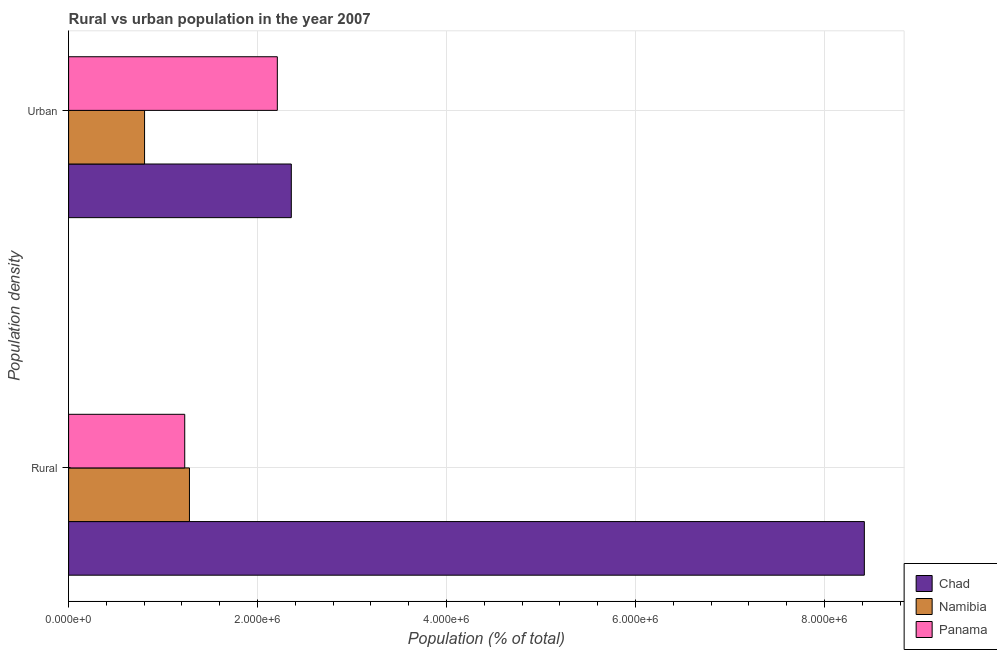Are the number of bars per tick equal to the number of legend labels?
Your answer should be compact. Yes. How many bars are there on the 2nd tick from the top?
Your response must be concise. 3. What is the label of the 2nd group of bars from the top?
Provide a short and direct response. Rural. What is the urban population density in Panama?
Keep it short and to the point. 2.21e+06. Across all countries, what is the maximum urban population density?
Offer a terse response. 2.36e+06. Across all countries, what is the minimum urban population density?
Keep it short and to the point. 8.04e+05. In which country was the rural population density maximum?
Offer a very short reply. Chad. In which country was the urban population density minimum?
Provide a short and direct response. Namibia. What is the total rural population density in the graph?
Provide a succinct answer. 1.09e+07. What is the difference between the urban population density in Chad and that in Panama?
Ensure brevity in your answer.  1.48e+05. What is the difference between the rural population density in Panama and the urban population density in Chad?
Your answer should be compact. -1.13e+06. What is the average rural population density per country?
Give a very brief answer. 3.64e+06. What is the difference between the urban population density and rural population density in Namibia?
Give a very brief answer. -4.75e+05. What is the ratio of the urban population density in Panama to that in Namibia?
Give a very brief answer. 2.75. What does the 1st bar from the top in Rural represents?
Your answer should be compact. Panama. What does the 3rd bar from the bottom in Rural represents?
Ensure brevity in your answer.  Panama. How many bars are there?
Offer a very short reply. 6. What is the difference between two consecutive major ticks on the X-axis?
Your answer should be very brief. 2.00e+06. Are the values on the major ticks of X-axis written in scientific E-notation?
Offer a very short reply. Yes. Where does the legend appear in the graph?
Provide a succinct answer. Bottom right. How many legend labels are there?
Ensure brevity in your answer.  3. What is the title of the graph?
Give a very brief answer. Rural vs urban population in the year 2007. Does "Armenia" appear as one of the legend labels in the graph?
Make the answer very short. No. What is the label or title of the X-axis?
Offer a very short reply. Population (% of total). What is the label or title of the Y-axis?
Ensure brevity in your answer.  Population density. What is the Population (% of total) in Chad in Rural?
Offer a very short reply. 8.42e+06. What is the Population (% of total) in Namibia in Rural?
Ensure brevity in your answer.  1.28e+06. What is the Population (% of total) of Panama in Rural?
Provide a short and direct response. 1.23e+06. What is the Population (% of total) in Chad in Urban?
Keep it short and to the point. 2.36e+06. What is the Population (% of total) of Namibia in Urban?
Make the answer very short. 8.04e+05. What is the Population (% of total) in Panama in Urban?
Ensure brevity in your answer.  2.21e+06. Across all Population density, what is the maximum Population (% of total) in Chad?
Give a very brief answer. 8.42e+06. Across all Population density, what is the maximum Population (% of total) of Namibia?
Make the answer very short. 1.28e+06. Across all Population density, what is the maximum Population (% of total) of Panama?
Provide a succinct answer. 2.21e+06. Across all Population density, what is the minimum Population (% of total) of Chad?
Offer a terse response. 2.36e+06. Across all Population density, what is the minimum Population (% of total) in Namibia?
Offer a very short reply. 8.04e+05. Across all Population density, what is the minimum Population (% of total) of Panama?
Make the answer very short. 1.23e+06. What is the total Population (% of total) in Chad in the graph?
Offer a very short reply. 1.08e+07. What is the total Population (% of total) of Namibia in the graph?
Keep it short and to the point. 2.08e+06. What is the total Population (% of total) in Panama in the graph?
Your answer should be compact. 3.44e+06. What is the difference between the Population (% of total) in Chad in Rural and that in Urban?
Make the answer very short. 6.06e+06. What is the difference between the Population (% of total) of Namibia in Rural and that in Urban?
Provide a succinct answer. 4.75e+05. What is the difference between the Population (% of total) in Panama in Rural and that in Urban?
Your answer should be very brief. -9.80e+05. What is the difference between the Population (% of total) in Chad in Rural and the Population (% of total) in Namibia in Urban?
Your answer should be compact. 7.62e+06. What is the difference between the Population (% of total) of Chad in Rural and the Population (% of total) of Panama in Urban?
Your answer should be compact. 6.21e+06. What is the difference between the Population (% of total) in Namibia in Rural and the Population (% of total) in Panama in Urban?
Offer a very short reply. -9.30e+05. What is the average Population (% of total) of Chad per Population density?
Your answer should be compact. 5.39e+06. What is the average Population (% of total) of Namibia per Population density?
Keep it short and to the point. 1.04e+06. What is the average Population (% of total) in Panama per Population density?
Provide a short and direct response. 1.72e+06. What is the difference between the Population (% of total) of Chad and Population (% of total) of Namibia in Rural?
Offer a very short reply. 7.14e+06. What is the difference between the Population (% of total) of Chad and Population (% of total) of Panama in Rural?
Keep it short and to the point. 7.19e+06. What is the difference between the Population (% of total) of Namibia and Population (% of total) of Panama in Rural?
Make the answer very short. 4.99e+04. What is the difference between the Population (% of total) in Chad and Population (% of total) in Namibia in Urban?
Provide a short and direct response. 1.55e+06. What is the difference between the Population (% of total) of Chad and Population (% of total) of Panama in Urban?
Make the answer very short. 1.48e+05. What is the difference between the Population (% of total) of Namibia and Population (% of total) of Panama in Urban?
Offer a terse response. -1.41e+06. What is the ratio of the Population (% of total) in Chad in Rural to that in Urban?
Make the answer very short. 3.57. What is the ratio of the Population (% of total) of Namibia in Rural to that in Urban?
Your answer should be compact. 1.59. What is the ratio of the Population (% of total) in Panama in Rural to that in Urban?
Your response must be concise. 0.56. What is the difference between the highest and the second highest Population (% of total) in Chad?
Give a very brief answer. 6.06e+06. What is the difference between the highest and the second highest Population (% of total) of Namibia?
Provide a succinct answer. 4.75e+05. What is the difference between the highest and the second highest Population (% of total) of Panama?
Ensure brevity in your answer.  9.80e+05. What is the difference between the highest and the lowest Population (% of total) in Chad?
Keep it short and to the point. 6.06e+06. What is the difference between the highest and the lowest Population (% of total) in Namibia?
Offer a very short reply. 4.75e+05. What is the difference between the highest and the lowest Population (% of total) of Panama?
Make the answer very short. 9.80e+05. 